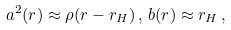<formula> <loc_0><loc_0><loc_500><loc_500>a ^ { 2 } ( r ) \approx \rho ( r - r _ { H } ) \, , \, b ( r ) \approx r _ { H } \, ,</formula> 